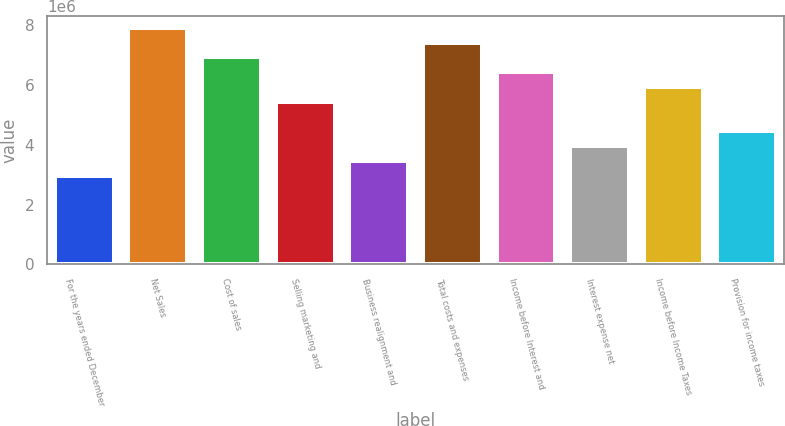Convert chart. <chart><loc_0><loc_0><loc_500><loc_500><bar_chart><fcel>For the years ended December<fcel>Net Sales<fcel>Cost of sales<fcel>Selling marketing and<fcel>Business realignment and<fcel>Total costs and expenses<fcel>Income before Interest and<fcel>Interest expense net<fcel>Income before Income Taxes<fcel>Provision for income taxes<nl><fcel>2.96654e+06<fcel>7.91077e+06<fcel>6.92192e+06<fcel>5.43865e+06<fcel>3.46096e+06<fcel>7.41634e+06<fcel>6.4275e+06<fcel>3.95538e+06<fcel>5.93308e+06<fcel>4.44981e+06<nl></chart> 